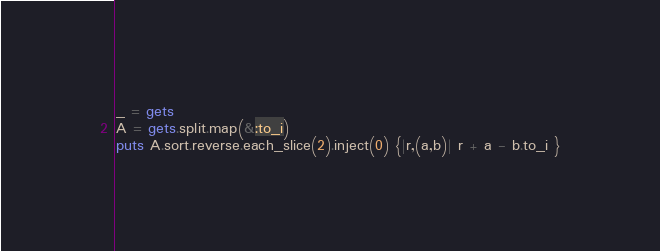Convert code to text. <code><loc_0><loc_0><loc_500><loc_500><_Ruby_>_ = gets
A = gets.split.map(&:to_i)
puts A.sort.reverse.each_slice(2).inject(0) {|r,(a,b)| r + a - b.to_i }
</code> 